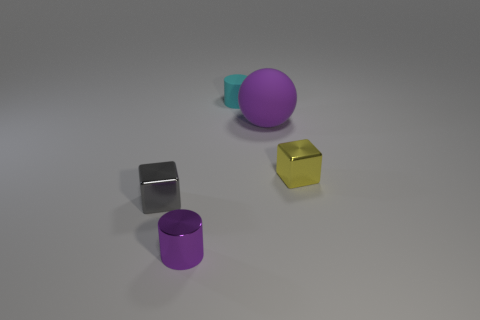Can you compare the colors and their visual appeal? Sure, the image features a visually harmonious color palette with a complementary color scheme. The yellow cube stands out due to its bright hue, creating a focal point. The purple objects have a cooler tone that provides depth, while the gray cube's neutrality balances the overall scene. 